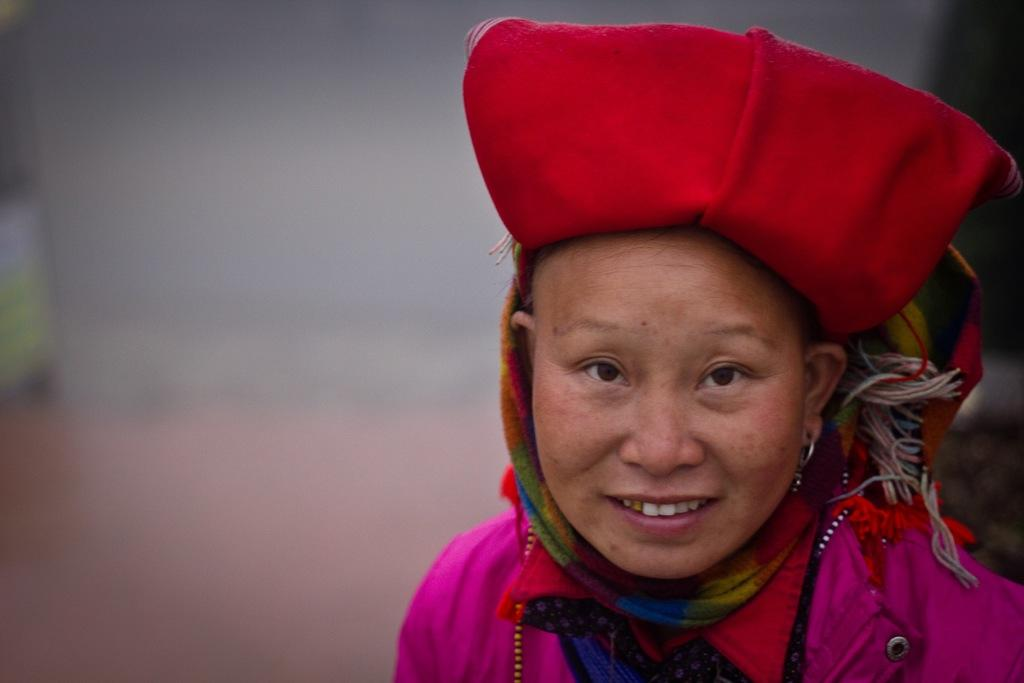What is the main subject of the image? There is a person in the image. What is the person's facial expression? The person is smiling. Can you describe the background of the image? The background of the image is blurred. What type of apparatus is being used by the person to maintain their balance in the image? There is no apparatus or indication of balance-related activities in the image; the person is simply standing and smiling. What sense is being stimulated by the person in the image? The image does not provide information about which sense is being stimulated by the person. 